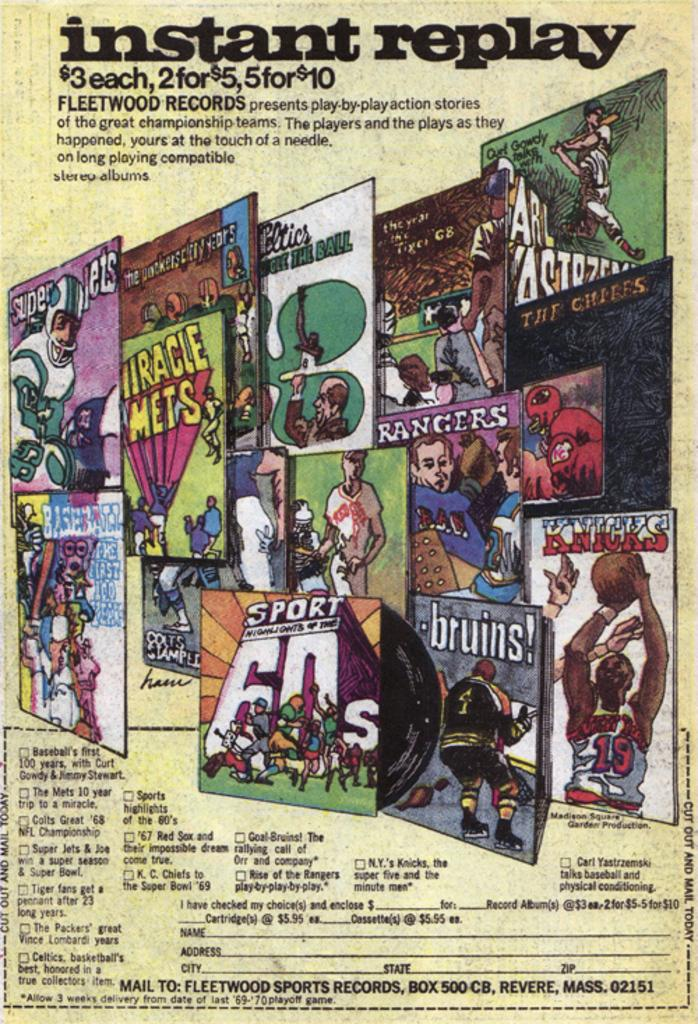What is present in the image that contains visual content? There is a poster in the image. What type of content is featured on the poster? The poster contains animated photos. Is there any text on the poster? Yes, there is some description printed on the poster. How many books are stacked on the poster in the image? There are no books present on the poster in the image. What type of trains can be seen passing by in the image? There are no trains visible in the image; it features a poster with animated photos and printed description. 